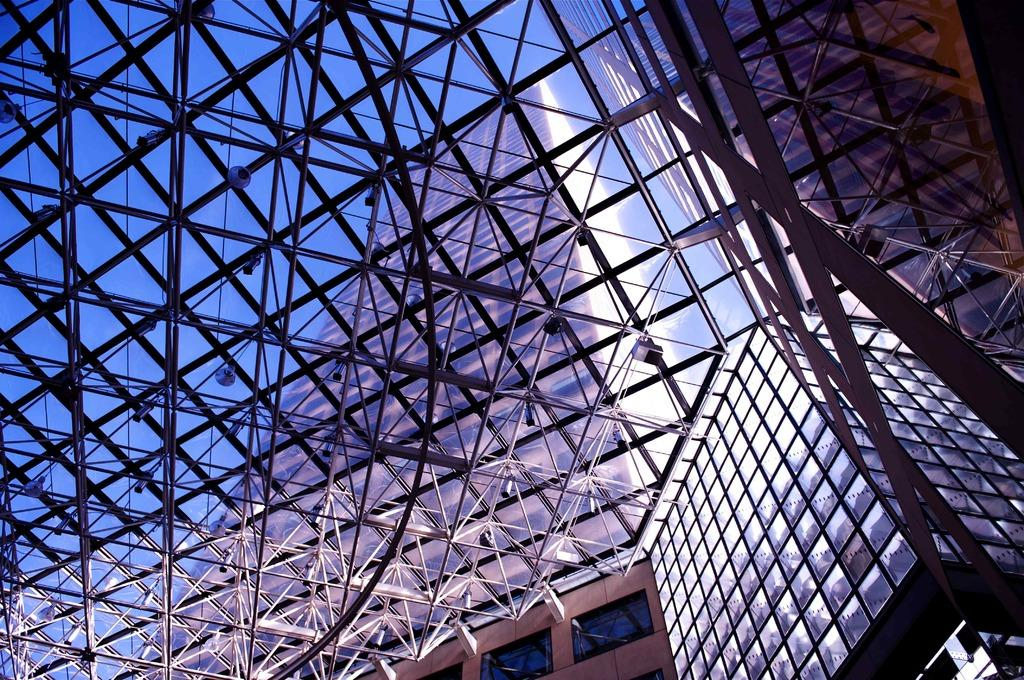What type of structure is visible in the image? There is a building in the image. Can you describe the design of the building? The building has an architectural design. What material is used for the rods in the image? The rods in the image are made of metal. What can be seen illuminating the area in the image? There are lights in the image. What type of coat is the cow wearing in the image? There is no cow or coat present in the image. 